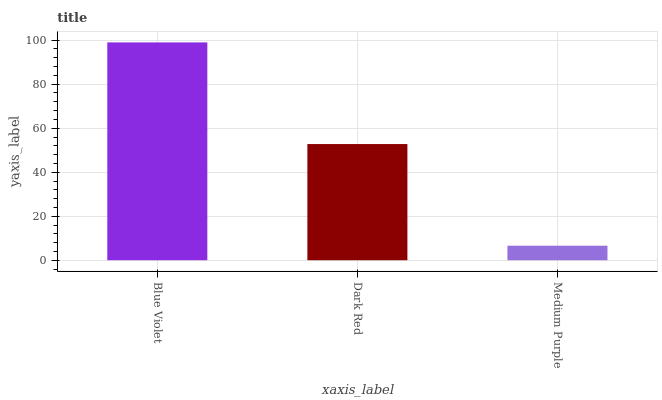Is Dark Red the minimum?
Answer yes or no. No. Is Dark Red the maximum?
Answer yes or no. No. Is Blue Violet greater than Dark Red?
Answer yes or no. Yes. Is Dark Red less than Blue Violet?
Answer yes or no. Yes. Is Dark Red greater than Blue Violet?
Answer yes or no. No. Is Blue Violet less than Dark Red?
Answer yes or no. No. Is Dark Red the high median?
Answer yes or no. Yes. Is Dark Red the low median?
Answer yes or no. Yes. Is Medium Purple the high median?
Answer yes or no. No. Is Medium Purple the low median?
Answer yes or no. No. 